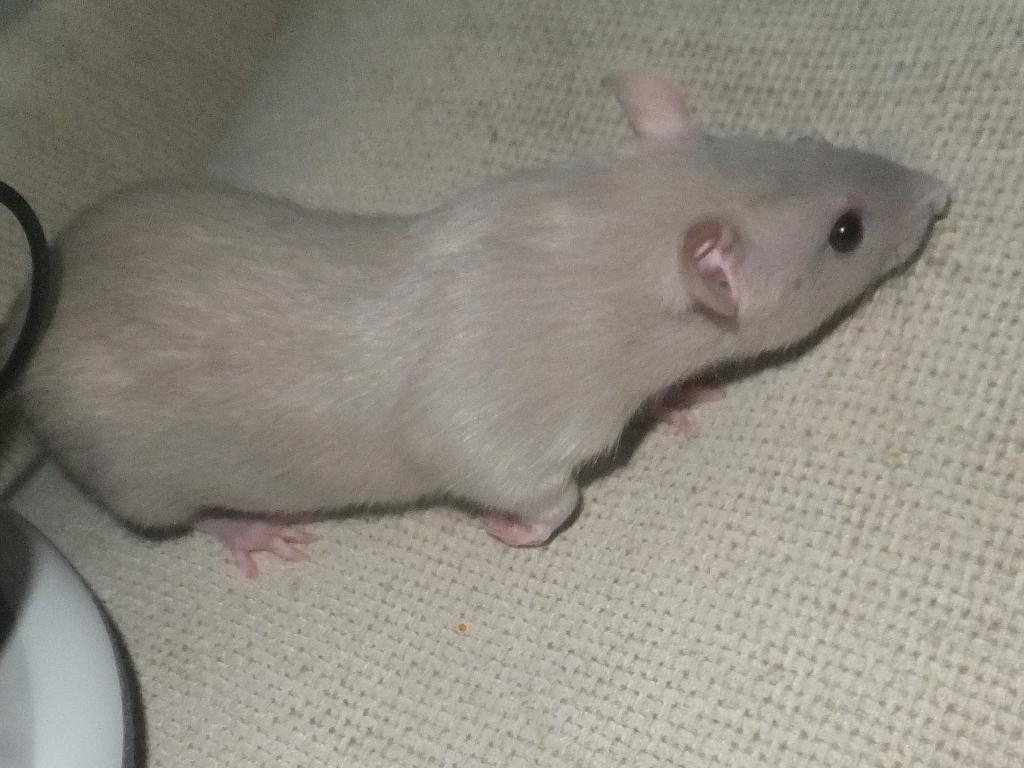What type of animal is present in the image? There is a rat in the image. Where is the rat located in the image? The rat is on a surface. What type of lipstick is the rat offering in the image? There is no lipstick or offering present in the image; it only features a rat on a surface. 